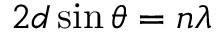Convert formula to latex. <formula><loc_0><loc_0><loc_500><loc_500>2 d \sin \theta = n \lambda</formula> 